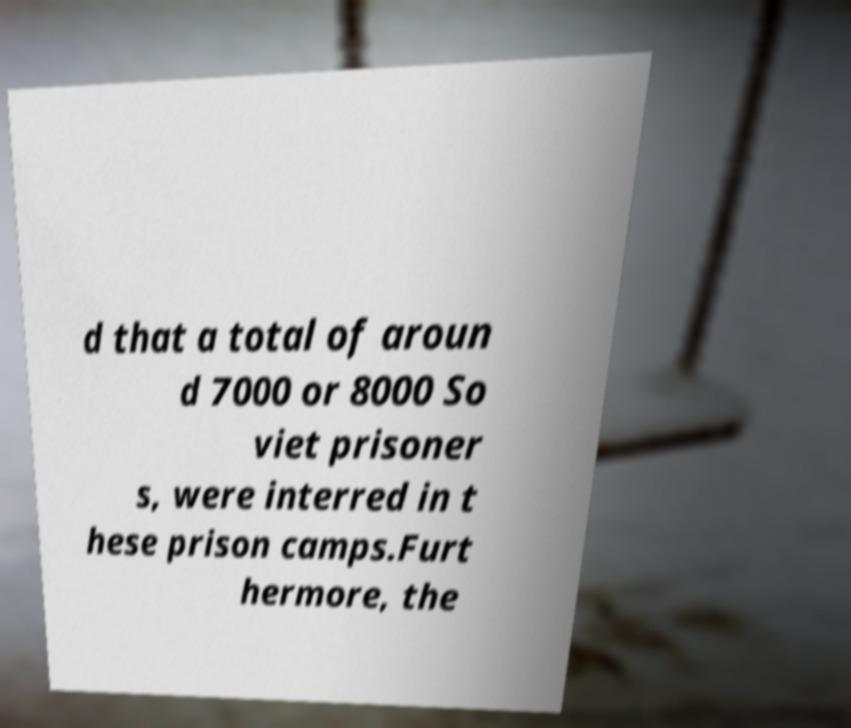Please read and relay the text visible in this image. What does it say? d that a total of aroun d 7000 or 8000 So viet prisoner s, were interred in t hese prison camps.Furt hermore, the 